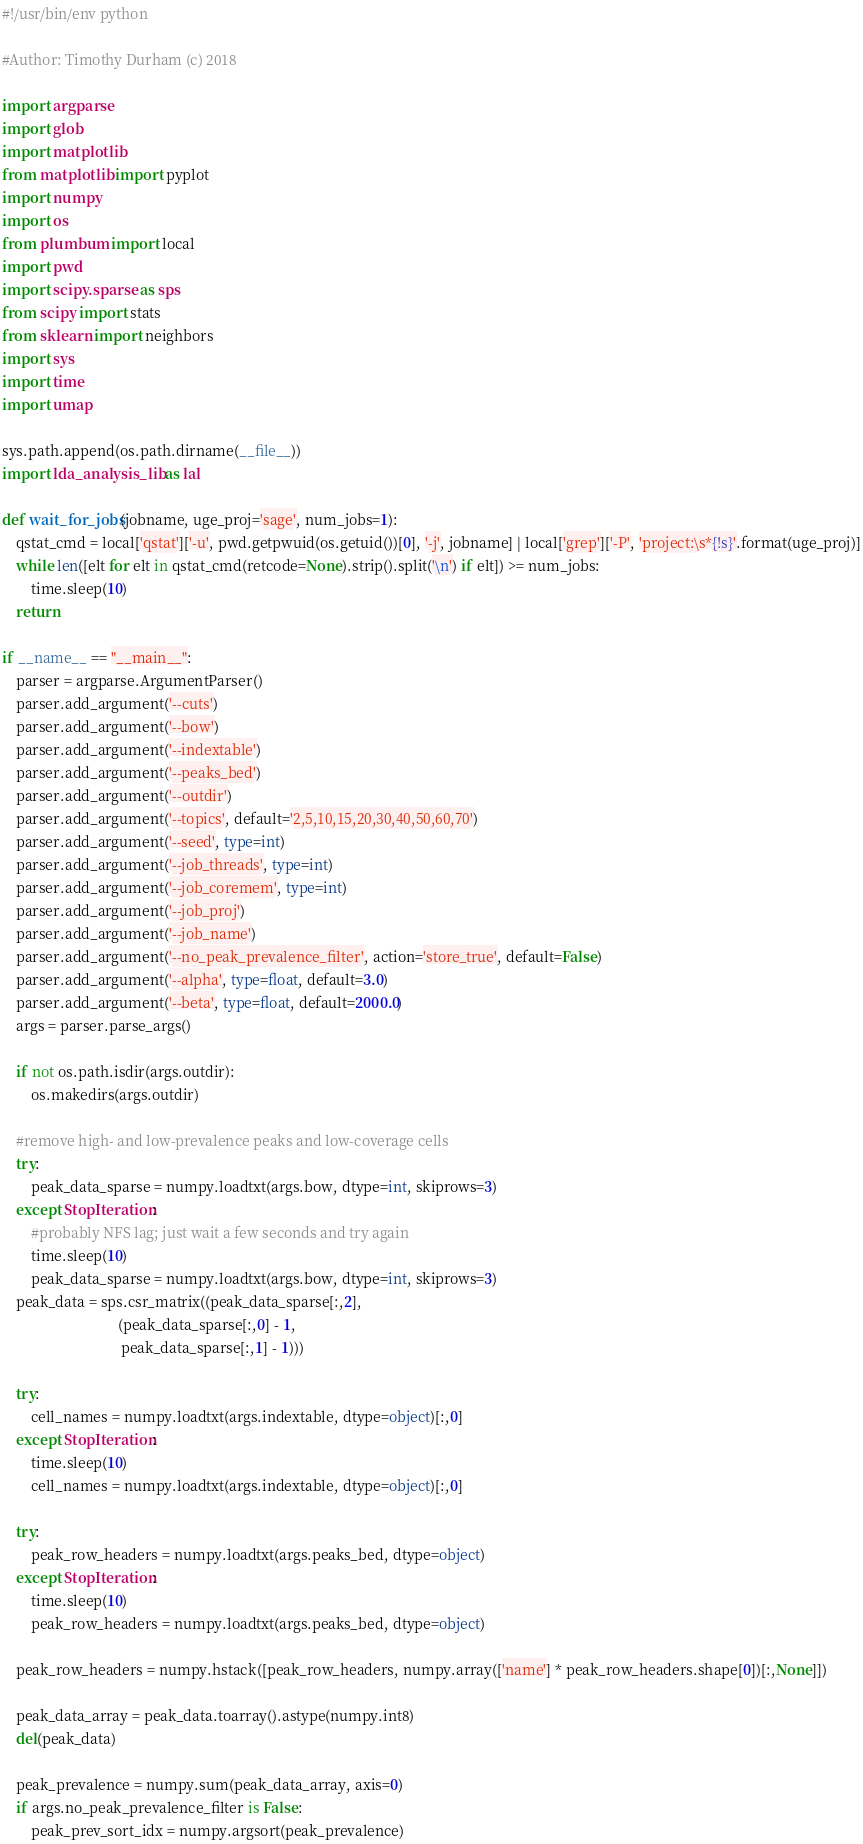Convert code to text. <code><loc_0><loc_0><loc_500><loc_500><_Python_>#!/usr/bin/env python

#Author: Timothy Durham (c) 2018

import argparse
import glob
import matplotlib
from matplotlib import pyplot
import numpy
import os
from plumbum import local
import pwd
import scipy.sparse as sps
from scipy import stats
from sklearn import neighbors
import sys
import time
import umap

sys.path.append(os.path.dirname(__file__))
import lda_analysis_lib as lal

def wait_for_jobs(jobname, uge_proj='sage', num_jobs=1):
    qstat_cmd = local['qstat']['-u', pwd.getpwuid(os.getuid())[0], '-j', jobname] | local['grep']['-P', 'project:\s*{!s}'.format(uge_proj)]
    while len([elt for elt in qstat_cmd(retcode=None).strip().split('\n') if elt]) >= num_jobs:
        time.sleep(10)
    return

if __name__ == "__main__":
    parser = argparse.ArgumentParser()
    parser.add_argument('--cuts')
    parser.add_argument('--bow')
    parser.add_argument('--indextable')
    parser.add_argument('--peaks_bed')
    parser.add_argument('--outdir')
    parser.add_argument('--topics', default='2,5,10,15,20,30,40,50,60,70')
    parser.add_argument('--seed', type=int)
    parser.add_argument('--job_threads', type=int)
    parser.add_argument('--job_coremem', type=int)
    parser.add_argument('--job_proj')
    parser.add_argument('--job_name')
    parser.add_argument('--no_peak_prevalence_filter', action='store_true', default=False)
    parser.add_argument('--alpha', type=float, default=3.0)
    parser.add_argument('--beta', type=float, default=2000.0)
    args = parser.parse_args()

    if not os.path.isdir(args.outdir):
        os.makedirs(args.outdir)

    #remove high- and low-prevalence peaks and low-coverage cells
    try:
        peak_data_sparse = numpy.loadtxt(args.bow, dtype=int, skiprows=3)
    except StopIteration:
        #probably NFS lag; just wait a few seconds and try again
        time.sleep(10)
        peak_data_sparse = numpy.loadtxt(args.bow, dtype=int, skiprows=3)
    peak_data = sps.csr_matrix((peak_data_sparse[:,2], 
                                (peak_data_sparse[:,0] - 1, 
                                 peak_data_sparse[:,1] - 1)))

    try:
        cell_names = numpy.loadtxt(args.indextable, dtype=object)[:,0]
    except StopIteration:
        time.sleep(10)
        cell_names = numpy.loadtxt(args.indextable, dtype=object)[:,0]

    try:
        peak_row_headers = numpy.loadtxt(args.peaks_bed, dtype=object)
    except StopIteration:
        time.sleep(10)
        peak_row_headers = numpy.loadtxt(args.peaks_bed, dtype=object)

    peak_row_headers = numpy.hstack([peak_row_headers, numpy.array(['name'] * peak_row_headers.shape[0])[:,None]])

    peak_data_array = peak_data.toarray().astype(numpy.int8)
    del(peak_data)

    peak_prevalence = numpy.sum(peak_data_array, axis=0)
    if args.no_peak_prevalence_filter is False:
        peak_prev_sort_idx = numpy.argsort(peak_prevalence)</code> 